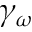Convert formula to latex. <formula><loc_0><loc_0><loc_500><loc_500>\gamma _ { \omega }</formula> 